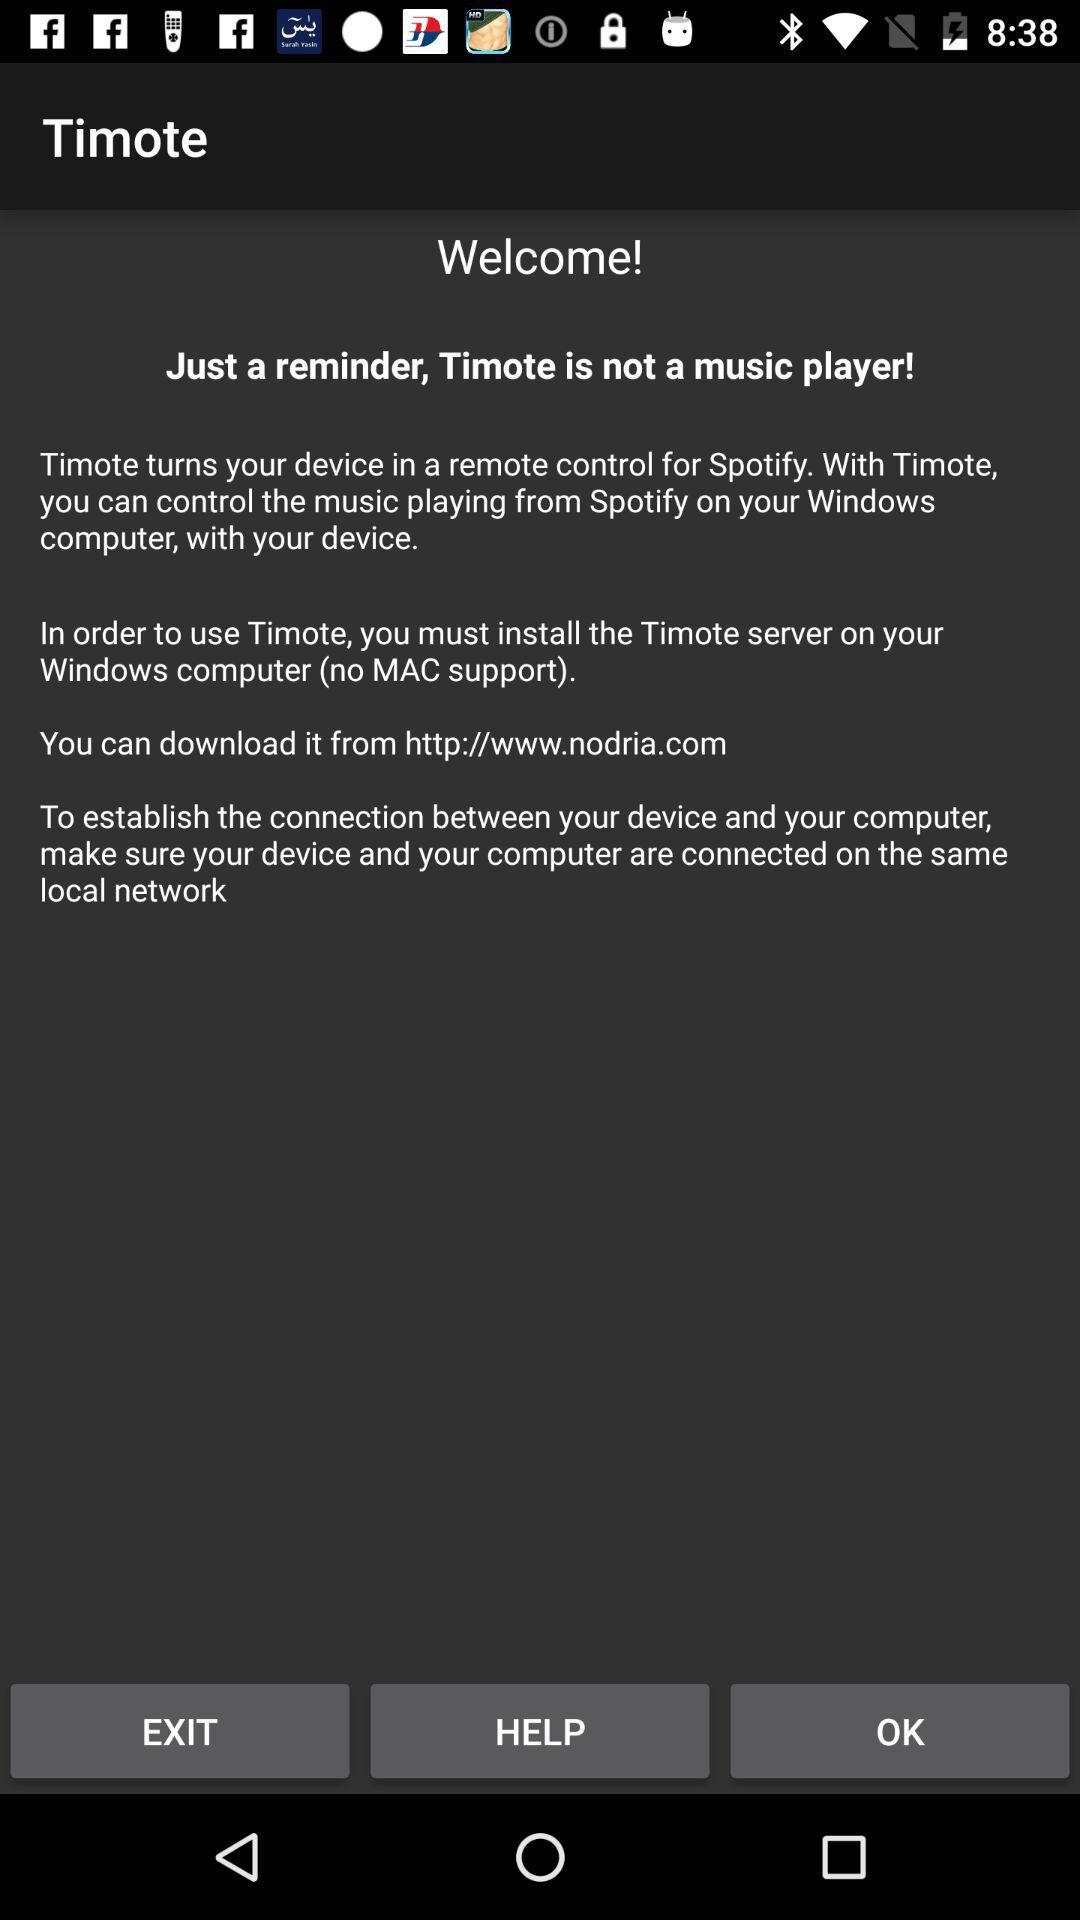What is the application name? The application name is "Timote". 